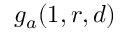Convert formula to latex. <formula><loc_0><loc_0><loc_500><loc_500>g _ { a } ( 1 , r , d )</formula> 